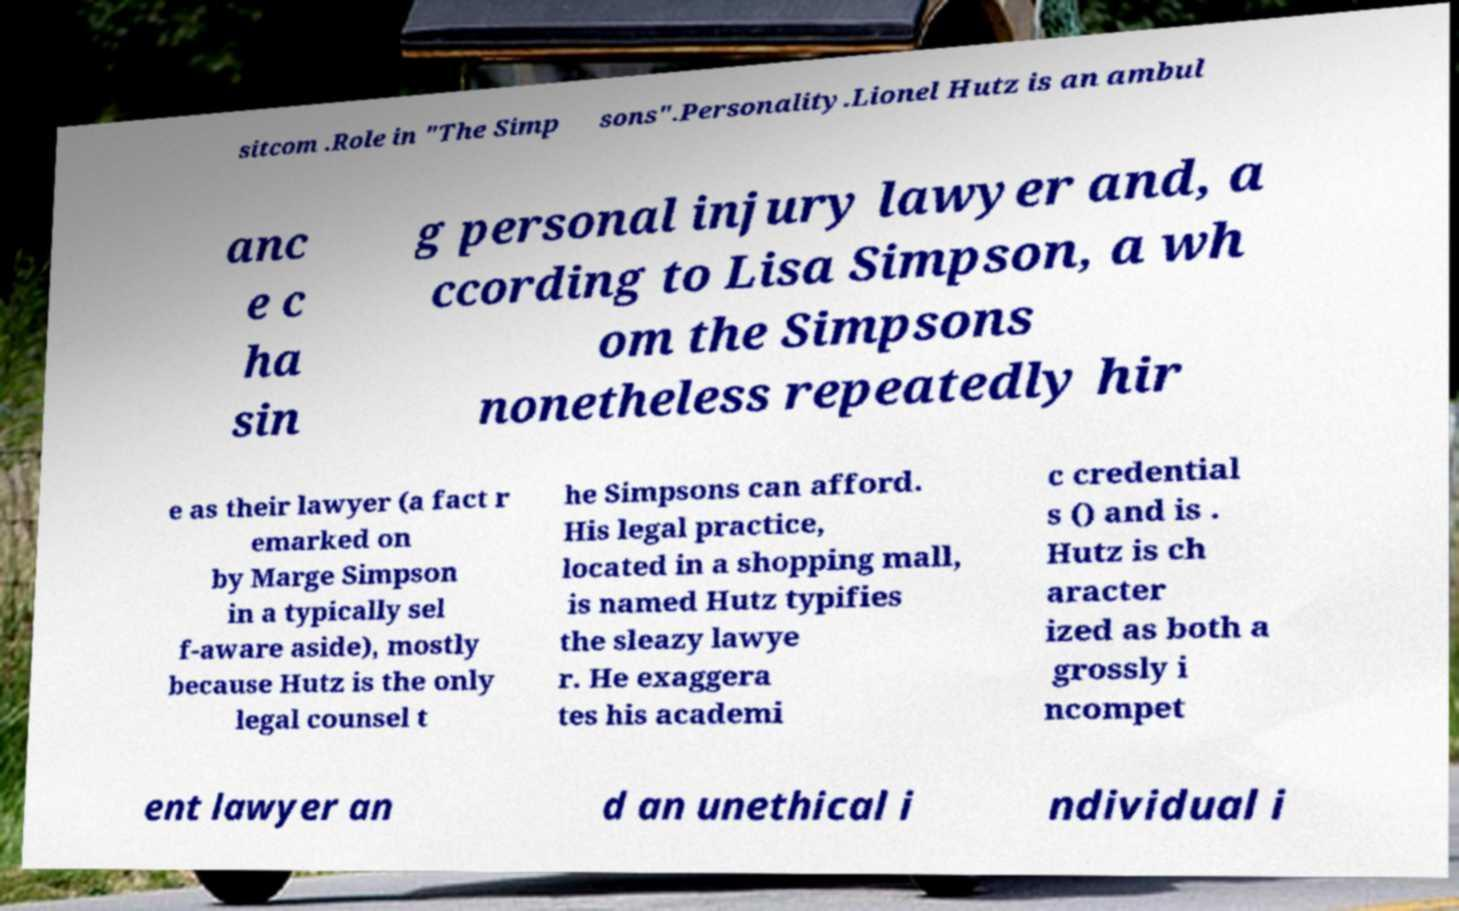Could you assist in decoding the text presented in this image and type it out clearly? sitcom .Role in "The Simp sons".Personality.Lionel Hutz is an ambul anc e c ha sin g personal injury lawyer and, a ccording to Lisa Simpson, a wh om the Simpsons nonetheless repeatedly hir e as their lawyer (a fact r emarked on by Marge Simpson in a typically sel f-aware aside), mostly because Hutz is the only legal counsel t he Simpsons can afford. His legal practice, located in a shopping mall, is named Hutz typifies the sleazy lawye r. He exaggera tes his academi c credential s () and is . Hutz is ch aracter ized as both a grossly i ncompet ent lawyer an d an unethical i ndividual i 